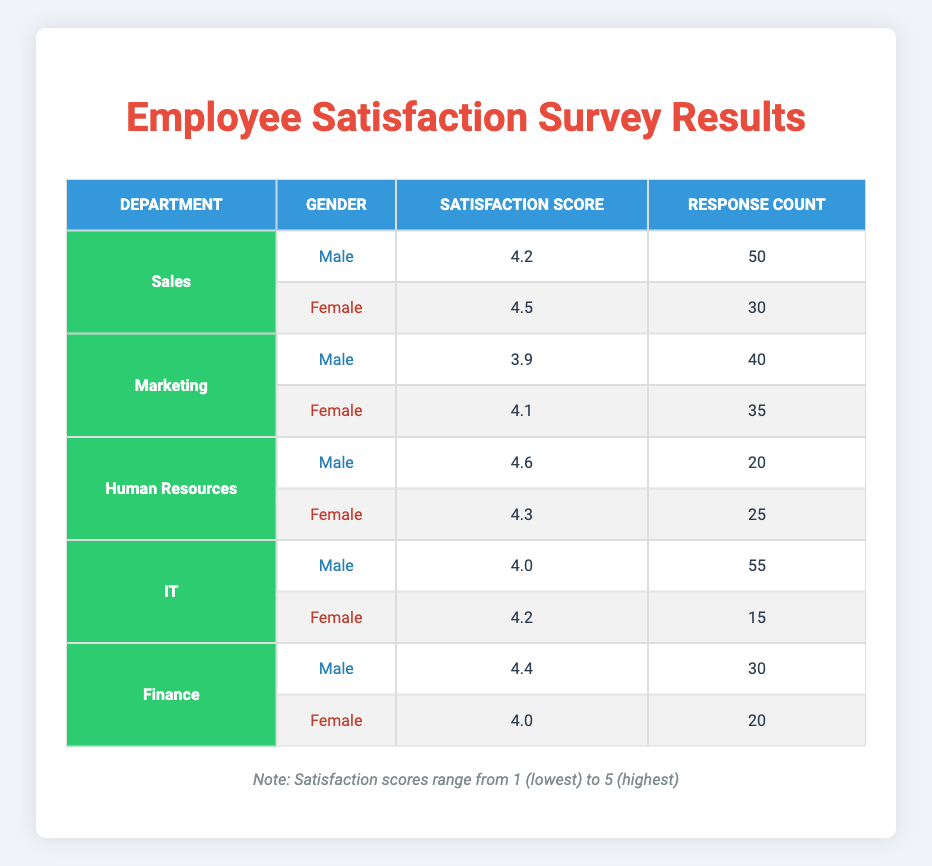What is the average satisfaction score for males in the Sales department? The satisfaction score for males in the Sales department is 4.2, and there is 1 data point. Therefore, the average is 4.2/1 = 4.2
Answer: 4.2 What is the satisfaction score for females in the Human Resources department? The satisfaction score for females in the Human Resources department is clearly listed as 4.3.
Answer: 4.3 Is the satisfaction score for males in the IT department higher than that of females in the same department? The satisfaction score for males in the IT department is 4.0, while the score for females is 4.2. Since 4.0 is less than 4.2, the statement is false.
Answer: No What department has the highest average satisfaction score across both genders? For each department: Sales has (4.2+4.5)/2 = 4.35, Marketing has (3.9+4.1)/2 = 4.0, Human Resources has (4.6+4.3)/2 = 4.45, IT has (4.0+4.2)/2 = 4.1, and Finance has (4.4+4.0)/2 = 4.2. The highest average is from Human Resources at 4.45.
Answer: Human Resources What is the total response count from females in the Finance department? From the table, the response count for females in the Finance department is listed as 20.
Answer: 20 Which gender has the highest satisfaction score in the Marketing department? In the Marketing department, males have a satisfaction score of 3.9, while females have a score of 4.1. Since 4.1 is greater than 3.9, females have the highest score.
Answer: Female What is the difference in satisfaction scores between males and females in the IT department? The satisfaction score for males in the IT department is 4.0 and for females is 4.2. The difference is 4.2 - 4.0 = 0.2.
Answer: 0.2 What percentage of responses from the Marketing department are women? The Marketing department has 40 responses from males and 35 from females. Total responses are 40 + 35 = 75. The percentage of responses from females is (35/75) * 100 = 46.67%.
Answer: 46.67% Are there any departments where male satisfaction scores exceed 4.5? Checking the satisfaction scores for males, Human Resources has the highest at 4.6, which exceeds 4.5. Therefore, there is at least one department where this is true.
Answer: Yes 